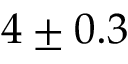Convert formula to latex. <formula><loc_0><loc_0><loc_500><loc_500>4 \pm 0 . 3</formula> 